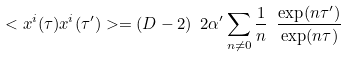Convert formula to latex. <formula><loc_0><loc_0><loc_500><loc_500>< x ^ { i } ( \tau ) x ^ { i } ( \tau ^ { \prime } ) > = ( D - 2 ) \ 2 \alpha ^ { \prime } \sum _ { n \neq 0 } \frac { 1 } { n } \ \frac { \exp ( n \tau ^ { \prime } ) } { \exp ( n \tau ) }</formula> 